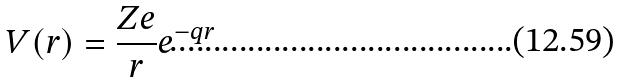Convert formula to latex. <formula><loc_0><loc_0><loc_500><loc_500>V ( r ) = \frac { Z e } { r } e ^ { - q r }</formula> 